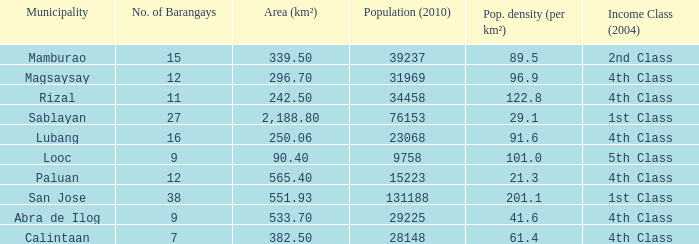What was the smallist population in 2010? 9758.0. Could you parse the entire table as a dict? {'header': ['Municipality', 'No. of Barangays', 'Area (km²)', 'Population (2010)', 'Pop. density (per km²)', 'Income Class (2004)'], 'rows': [['Mamburao', '15', '339.50', '39237', '89.5', '2nd Class'], ['Magsaysay', '12', '296.70', '31969', '96.9', '4th Class'], ['Rizal', '11', '242.50', '34458', '122.8', '4th Class'], ['Sablayan', '27', '2,188.80', '76153', '29.1', '1st Class'], ['Lubang', '16', '250.06', '23068', '91.6', '4th Class'], ['Looc', '9', '90.40', '9758', '101.0', '5th Class'], ['Paluan', '12', '565.40', '15223', '21.3', '4th Class'], ['San Jose', '38', '551.93', '131188', '201.1', '1st Class'], ['Abra de Ilog', '9', '533.70', '29225', '41.6', '4th Class'], ['Calintaan', '7', '382.50', '28148', '61.4', '4th Class']]} 